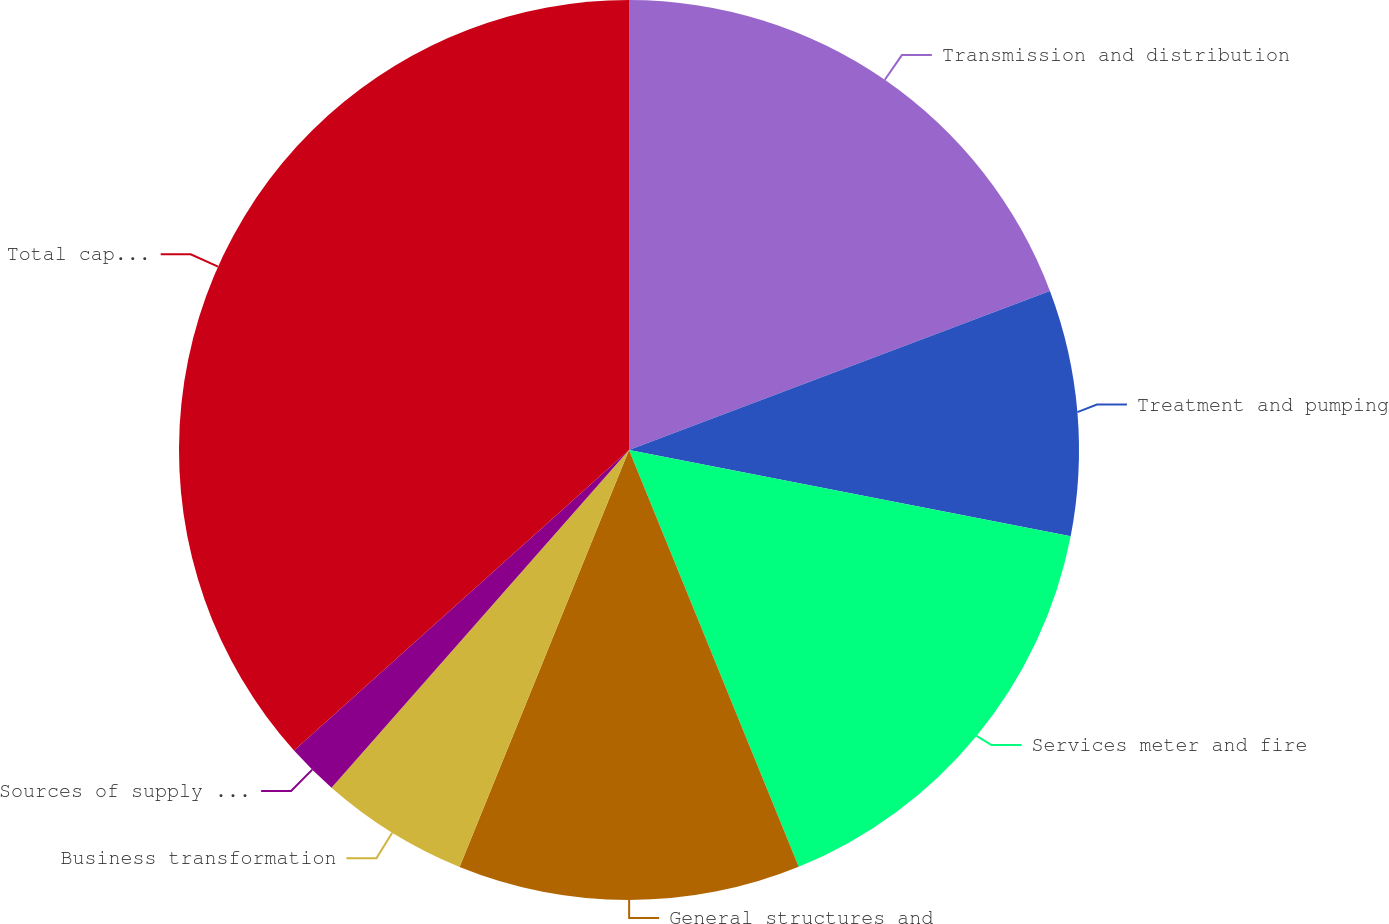Convert chart. <chart><loc_0><loc_0><loc_500><loc_500><pie_chart><fcel>Transmission and distribution<fcel>Treatment and pumping<fcel>Services meter and fire<fcel>General structures and<fcel>Business transformation<fcel>Sources of supply Wastewater<fcel>Total capital expenditures<nl><fcel>19.25%<fcel>8.82%<fcel>15.78%<fcel>12.3%<fcel>5.35%<fcel>1.87%<fcel>36.64%<nl></chart> 